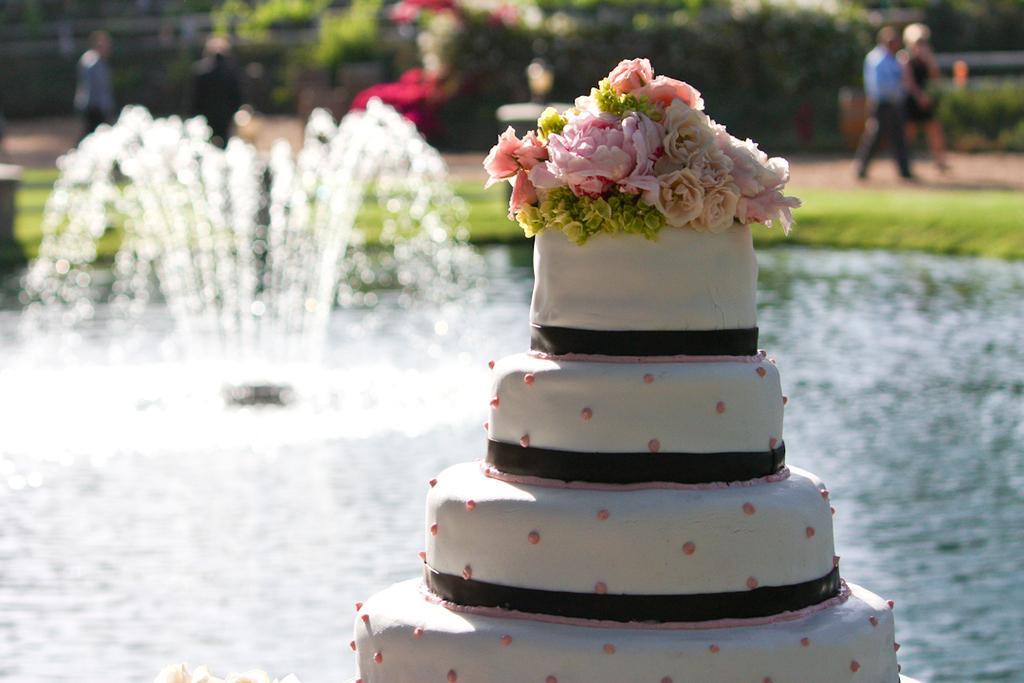In one or two sentences, can you explain what this image depicts? In the foreground I can see a cake, water and a fountain. In the background I can see grass, plants, trees and a group of people on the road. This image is taken, may be in a park. 